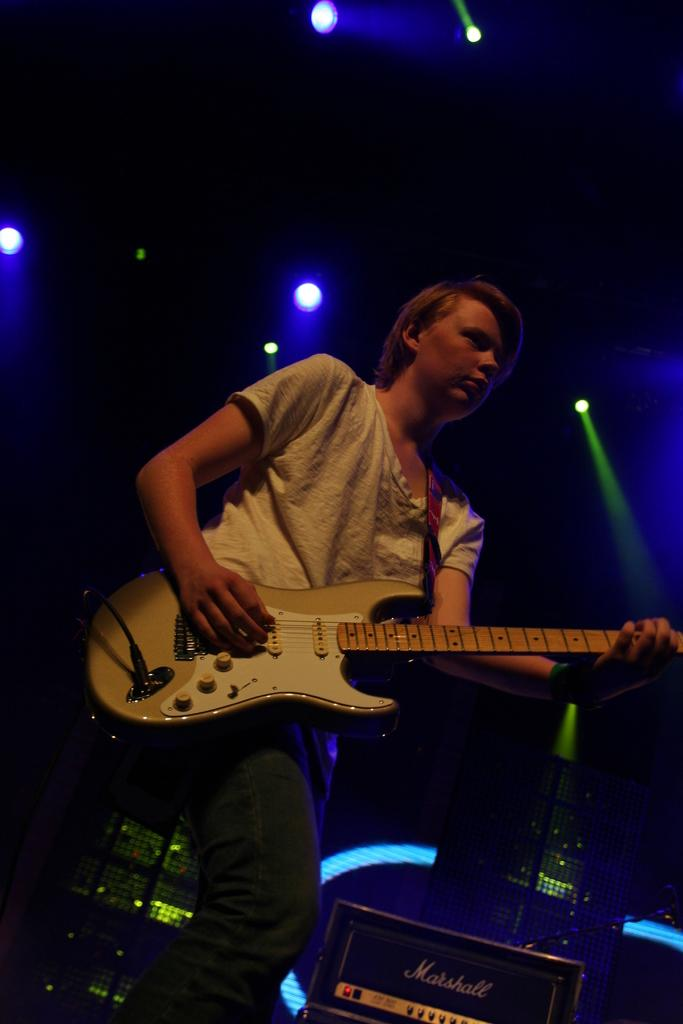What is the main subject of the image? There is a person in the image. What is the person wearing? The person is wearing a white shirt. What is the person holding in the image? The person is holding a guitar. What is the person doing with the guitar? The person is playing the guitar. What other objects can be seen in the image? There are speakers visible in the image. What is on the roof in the image? There are lights on the roof in the image. Can you see any cobwebs on the guitar in the image? There are no cobwebs visible on the guitar in the image. How much does the dog weigh in the image? There is no dog present in the image, so its weight cannot be determined. 